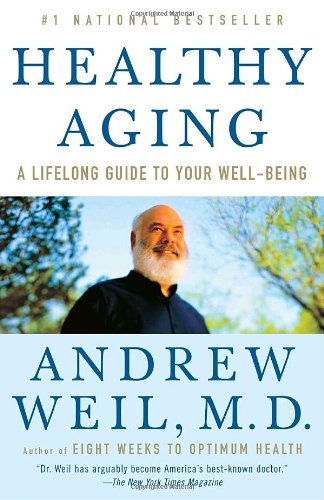What is the title of this book? The title of this well-known health book is 'Healthy Aging: A Lifelong Guide to Your Well-Being,' a detailed guide focusing on maintaining health as one ages. 